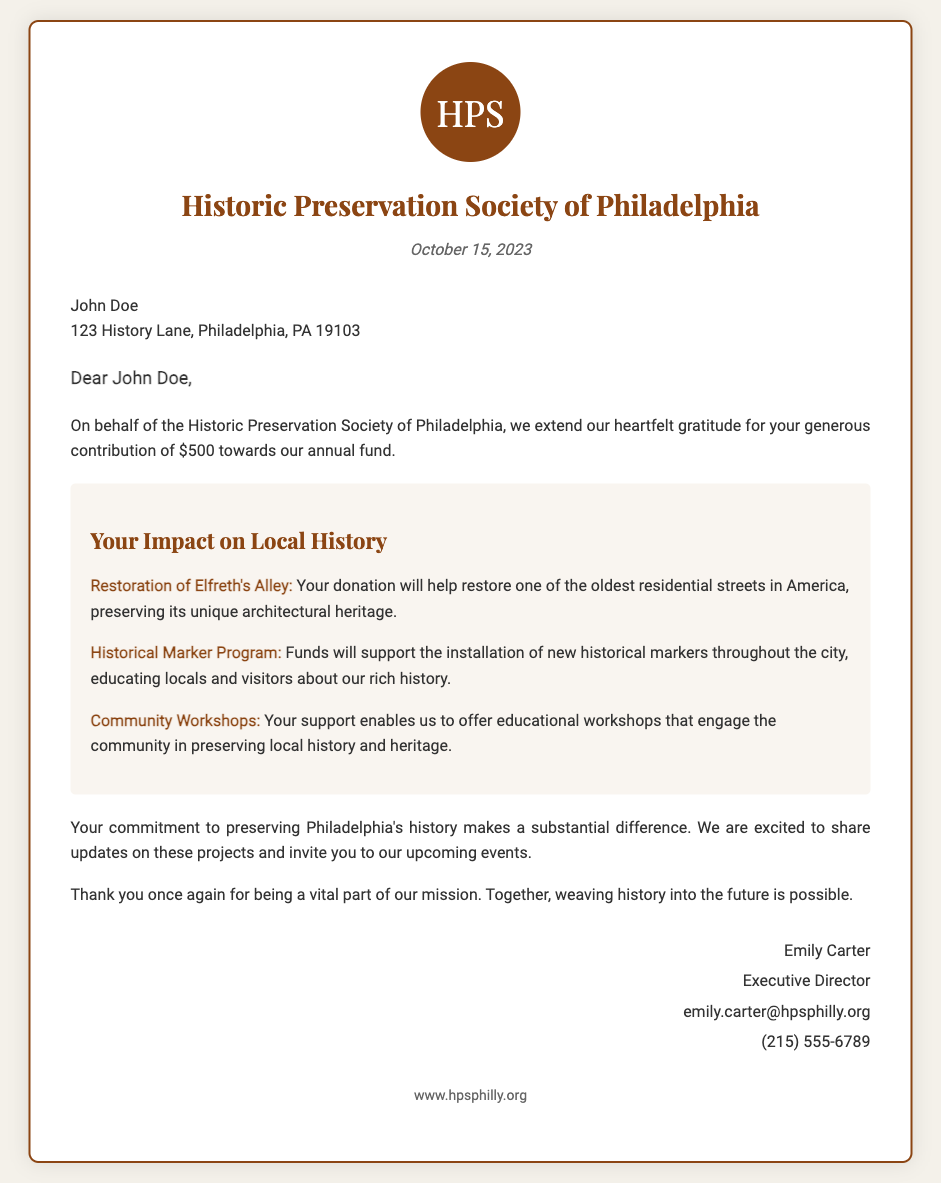What is the organization's name? The organization is identified as the Historic Preservation Society of Philadelphia.
Answer: Historic Preservation Society of Philadelphia What is the donation amount? The document specifies the donation amount as $500.
Answer: $500 Who is the recipient of the letter? The document addresses the donation acknowledgment to John Doe.
Answer: John Doe What date is mentioned in the letter? The date on the letter is stated as October 15, 2023.
Answer: October 15, 2023 What project involves restoring one of the oldest residential streets? The project mentioned is the Restoration of Elfreth's Alley.
Answer: Restoration of Elfreth's Alley What is one use of the funds besides restoration? Funds are also used for the Historical Marker Program.
Answer: Historical Marker Program What kind of educational opportunities does the donation support? The donation supports Community Workshops.
Answer: Community Workshops Who signed the letter? The letter is signed by Emily Carter.
Answer: Emily Carter What is the contact email provided in the letter? The contact email listed is emily.carter@hpsphilly.org.
Answer: emily.carter@hpsphilly.org 